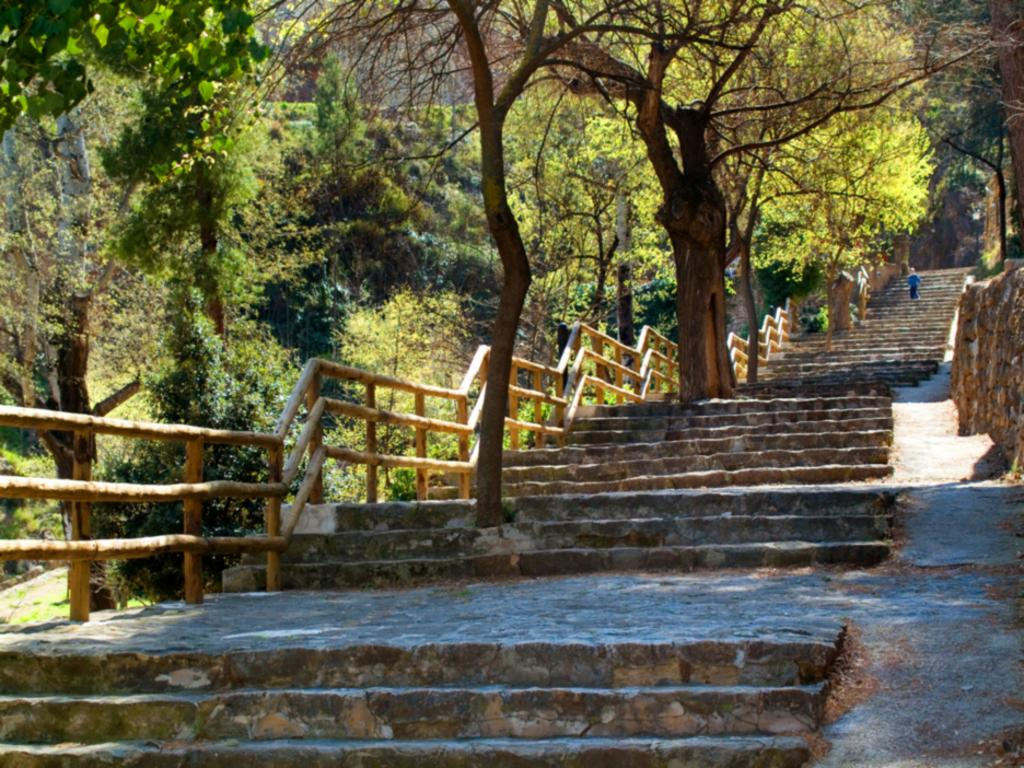What is the main feature of the image? There are many stairs in the image. What is associated with the stairs for safety purposes? There is a railing associated with the stairs. What is the person in the image doing? A person is walking on the stairs. What can be seen in the background of the image? There are many trees in the background of the image. What type of book is the person reading while walking on the stairs? There is no book present in the image, and the person is not reading while walking on the stairs. What color is the sky in the image? The provided facts do not mention the color of the sky, and it is not visible in the image. 